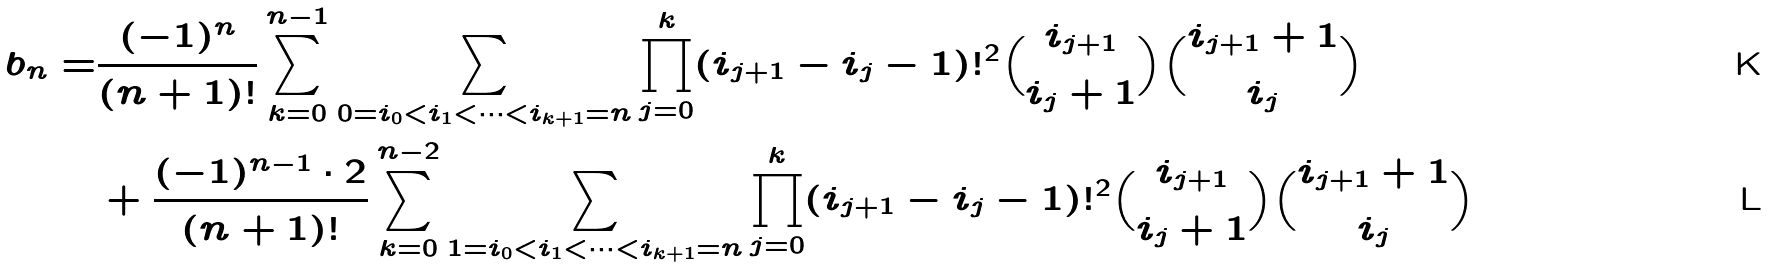Convert formula to latex. <formula><loc_0><loc_0><loc_500><loc_500>b _ { n } = & \frac { ( - 1 ) ^ { n } } { ( n + 1 ) ! } \sum _ { k = 0 } ^ { n - 1 } \sum _ { 0 = i _ { 0 } < i _ { 1 } < \cdots < i _ { k + 1 } = n } \prod _ { j = 0 } ^ { k } ( i _ { j + 1 } - i _ { j } - 1 ) ! ^ { 2 } \binom { i _ { j + 1 } } { i _ { j } + 1 } \binom { i _ { j + 1 } + 1 } { i _ { j } } \\ & + \frac { ( - 1 ) ^ { n - 1 } \cdot 2 } { ( n + 1 ) ! } \sum _ { k = 0 } ^ { n - 2 } \sum _ { 1 = i _ { 0 } < i _ { 1 } < \cdots < i _ { k + 1 } = n } \prod _ { j = 0 } ^ { k } ( i _ { j + 1 } - i _ { j } - 1 ) ! ^ { 2 } \binom { i _ { j + 1 } } { i _ { j } + 1 } \binom { i _ { j + 1 } + 1 } { i _ { j } }</formula> 